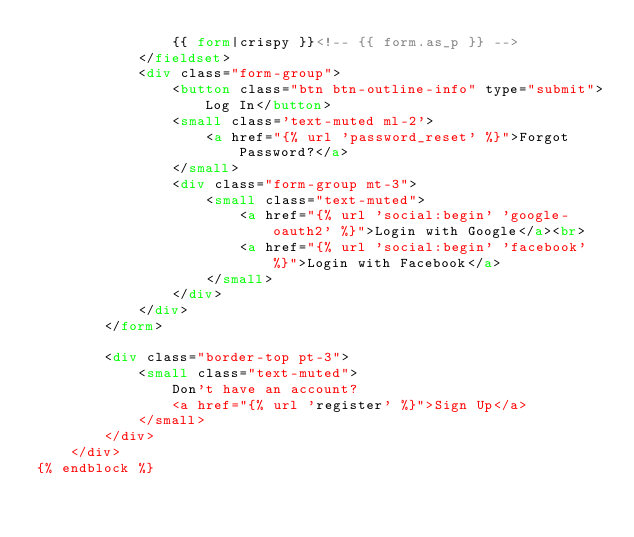Convert code to text. <code><loc_0><loc_0><loc_500><loc_500><_HTML_>				{{ form|crispy }}<!-- {{ form.as_p }} -->
			</fieldset>
			<div class="form-group">
				<button class="btn btn-outline-info" type="submit">Log In</button>
				<small class='text-muted ml-2'>
					<a href="{% url 'password_reset' %}">Forgot Password?</a>
				</small>
				<div class="form-group mt-3">
					<small class="text-muted">
						<a href="{% url 'social:begin' 'google-oauth2' %}">Login with Google</a><br>
						<a href="{% url 'social:begin' 'facebook' %}">Login with Facebook</a>
					</small>
				</div>
			</div>
		</form>

		<div class="border-top pt-3">
			<small class="text-muted">
				Don't have an account? 
				<a href="{% url 'register' %}">Sign Up</a>
			</small>
		</div>
	</div>
{% endblock %}
</code> 